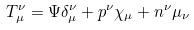<formula> <loc_0><loc_0><loc_500><loc_500>T _ { \mu } ^ { \nu } = \Psi \delta _ { \mu } ^ { \nu } + p ^ { \nu } \chi _ { \mu } + n ^ { \nu } \mu _ { \nu }</formula> 